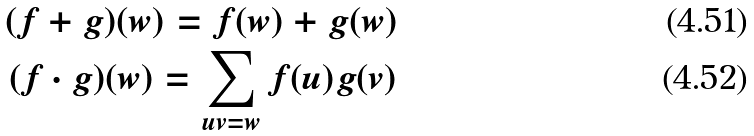Convert formula to latex. <formula><loc_0><loc_0><loc_500><loc_500>( f + g ) ( w ) = f ( w ) + g ( w ) \\ ( f \cdot g ) ( w ) = \sum _ { u v = w } f ( u ) g ( v )</formula> 